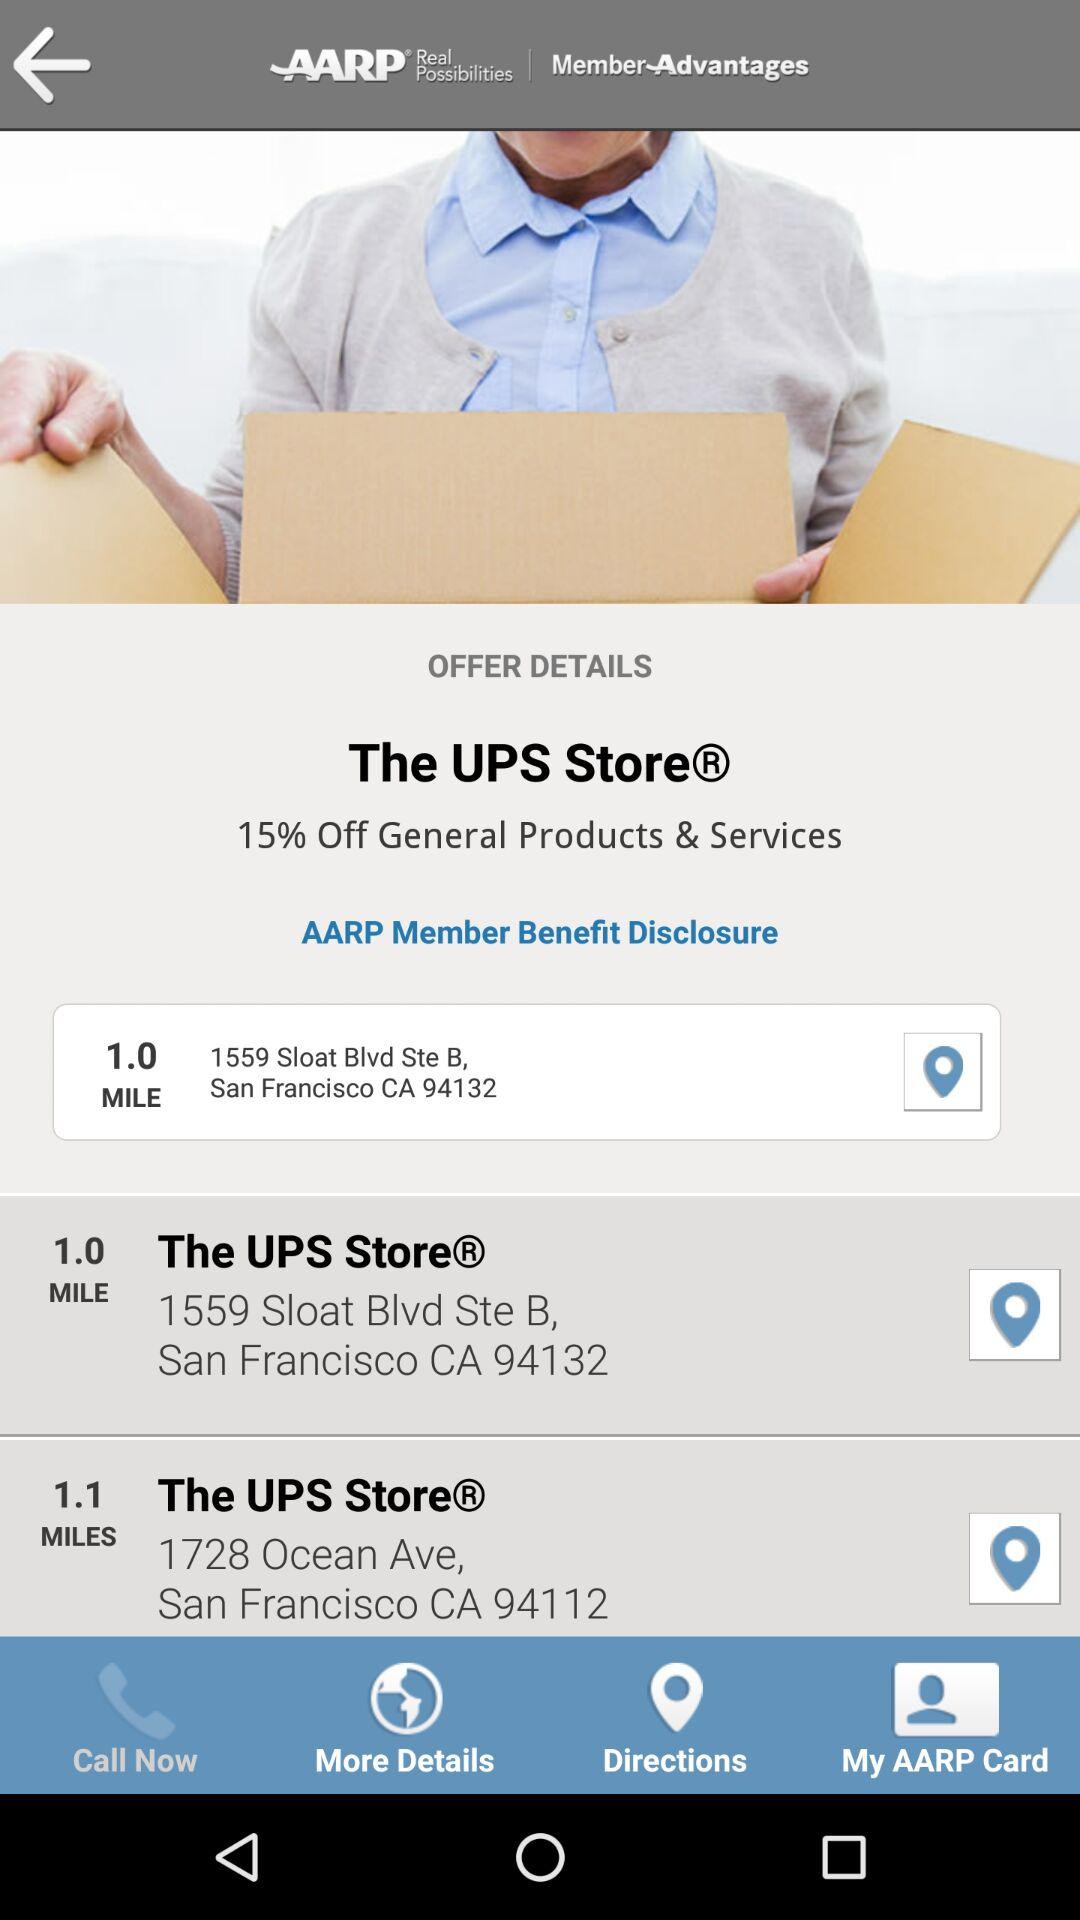How far is the UPS store?
When the provided information is insufficient, respond with <no answer>. <no answer> 